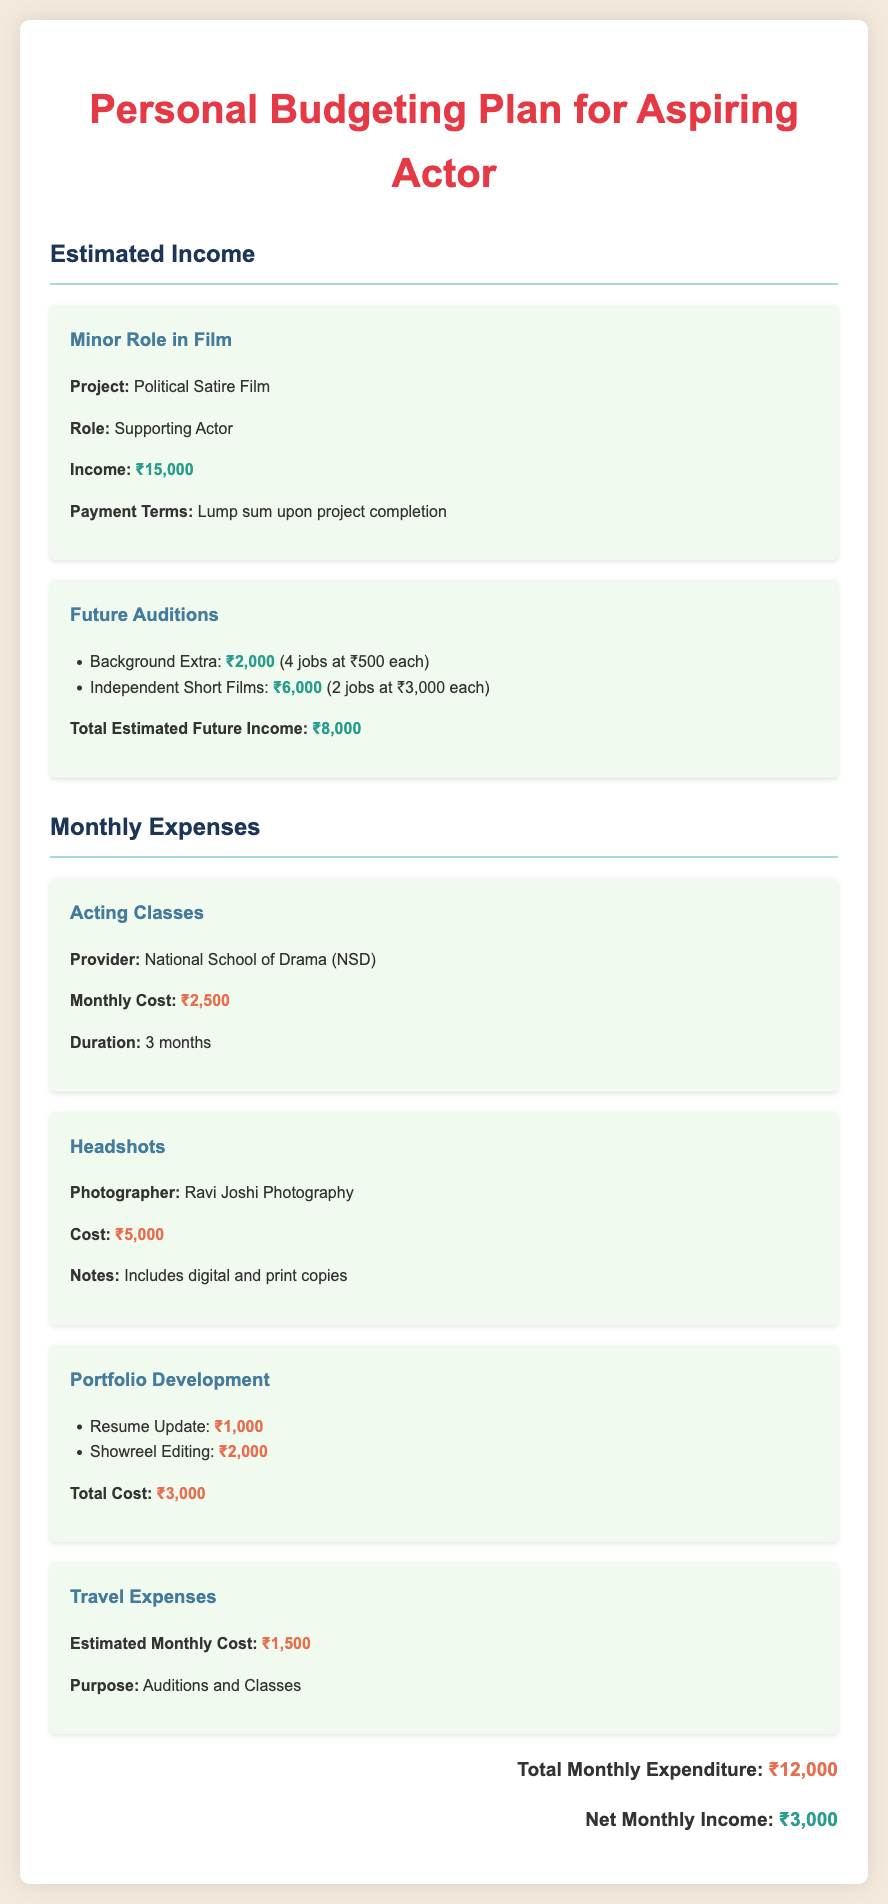What is the income from the minor role in the film? The income from the minor role in the film is specifically listed in the document as ₹15,000.
Answer: ₹15,000 How much do acting classes cost per month? The monthly cost for acting classes at the National School of Drama is mentioned as ₹2,500.
Answer: ₹2,500 What is the total cost for portfolio development? The total cost for portfolio development, which includes resume update and showreel editing, is summarized in the document as ₹3,000.
Answer: ₹3,000 What is the estimated monthly travel expense? The estimated monthly cost for travel expenses is provided as ₹1,500 in the document.
Answer: ₹1,500 How much income is expected from future auditions? The document states that the total estimated future income from potential auditions is ₹8,000.
Answer: ₹8,000 What is the net monthly income after expenses? The net monthly income is calculated as total income minus total expenditure, stated in the document as ₹3,000.
Answer: ₹3,000 Which photographer is mentioned for headshots? The photographer for headshots is listed in the document as Ravi Joshi Photography.
Answer: Ravi Joshi Photography How many months do the acting classes last? The document specifies that the duration of the acting classes is 3 months.
Answer: 3 months What is the total monthly expenditure? The total monthly expenditure is provided in the document as ₹12,000.
Answer: ₹12,000 